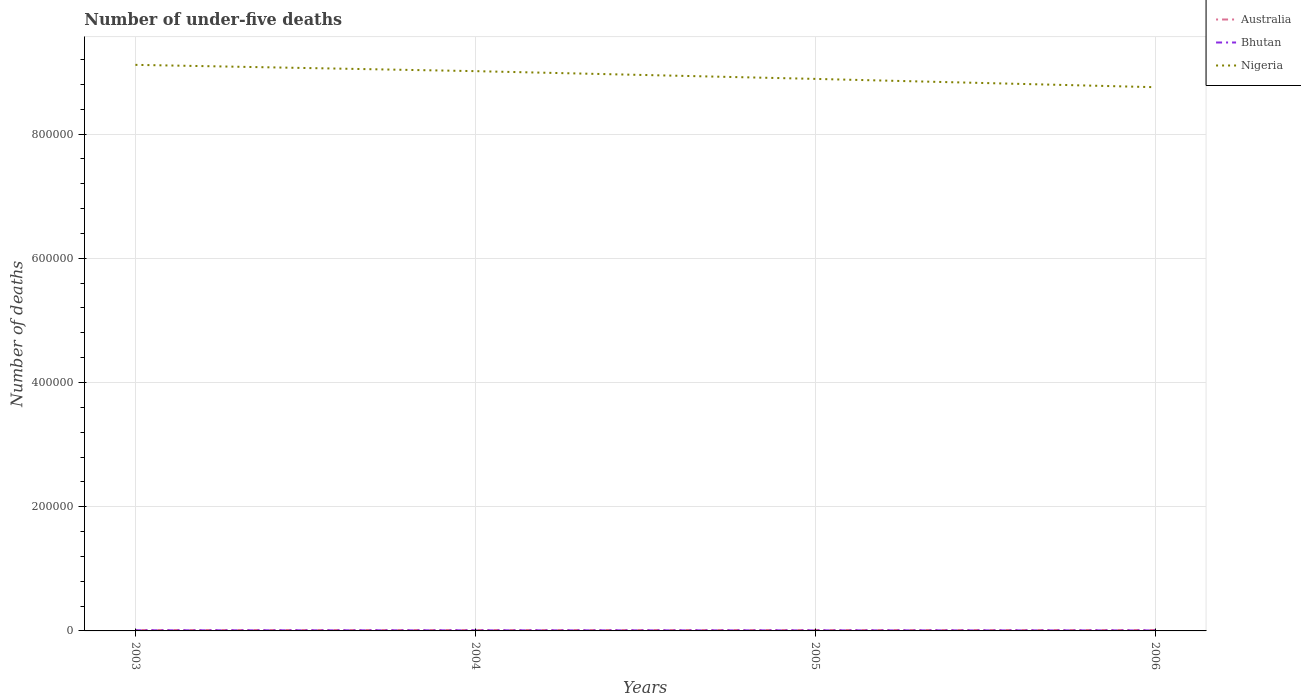How many different coloured lines are there?
Give a very brief answer. 3. Does the line corresponding to Bhutan intersect with the line corresponding to Nigeria?
Offer a terse response. No. Across all years, what is the maximum number of under-five deaths in Bhutan?
Ensure brevity in your answer.  812. What is the total number of under-five deaths in Nigeria in the graph?
Make the answer very short. 3.60e+04. What is the difference between the highest and the second highest number of under-five deaths in Australia?
Provide a succinct answer. 24. What is the difference between the highest and the lowest number of under-five deaths in Bhutan?
Your response must be concise. 2. Is the number of under-five deaths in Nigeria strictly greater than the number of under-five deaths in Bhutan over the years?
Make the answer very short. No. How many lines are there?
Your answer should be compact. 3. How many years are there in the graph?
Your answer should be compact. 4. What is the difference between two consecutive major ticks on the Y-axis?
Offer a very short reply. 2.00e+05. Does the graph contain any zero values?
Your response must be concise. No. Does the graph contain grids?
Keep it short and to the point. Yes. Where does the legend appear in the graph?
Your answer should be compact. Top right. How many legend labels are there?
Offer a terse response. 3. How are the legend labels stacked?
Ensure brevity in your answer.  Vertical. What is the title of the graph?
Ensure brevity in your answer.  Number of under-five deaths. What is the label or title of the X-axis?
Give a very brief answer. Years. What is the label or title of the Y-axis?
Make the answer very short. Number of deaths. What is the Number of deaths in Australia in 2003?
Provide a short and direct response. 1472. What is the Number of deaths of Bhutan in 2003?
Give a very brief answer. 1003. What is the Number of deaths of Nigeria in 2003?
Make the answer very short. 9.12e+05. What is the Number of deaths of Australia in 2004?
Provide a succinct answer. 1470. What is the Number of deaths of Bhutan in 2004?
Your response must be concise. 926. What is the Number of deaths of Nigeria in 2004?
Give a very brief answer. 9.01e+05. What is the Number of deaths of Australia in 2005?
Your response must be concise. 1458. What is the Number of deaths in Bhutan in 2005?
Your answer should be very brief. 862. What is the Number of deaths of Nigeria in 2005?
Offer a very short reply. 8.89e+05. What is the Number of deaths of Australia in 2006?
Your answer should be compact. 1482. What is the Number of deaths in Bhutan in 2006?
Offer a terse response. 812. What is the Number of deaths of Nigeria in 2006?
Offer a terse response. 8.76e+05. Across all years, what is the maximum Number of deaths in Australia?
Offer a terse response. 1482. Across all years, what is the maximum Number of deaths in Bhutan?
Your response must be concise. 1003. Across all years, what is the maximum Number of deaths of Nigeria?
Ensure brevity in your answer.  9.12e+05. Across all years, what is the minimum Number of deaths of Australia?
Your response must be concise. 1458. Across all years, what is the minimum Number of deaths of Bhutan?
Make the answer very short. 812. Across all years, what is the minimum Number of deaths of Nigeria?
Your answer should be very brief. 8.76e+05. What is the total Number of deaths in Australia in the graph?
Make the answer very short. 5882. What is the total Number of deaths of Bhutan in the graph?
Give a very brief answer. 3603. What is the total Number of deaths of Nigeria in the graph?
Your response must be concise. 3.58e+06. What is the difference between the Number of deaths of Australia in 2003 and that in 2004?
Your answer should be very brief. 2. What is the difference between the Number of deaths in Bhutan in 2003 and that in 2004?
Your answer should be compact. 77. What is the difference between the Number of deaths in Nigeria in 2003 and that in 2004?
Your response must be concise. 1.01e+04. What is the difference between the Number of deaths in Australia in 2003 and that in 2005?
Provide a short and direct response. 14. What is the difference between the Number of deaths of Bhutan in 2003 and that in 2005?
Provide a succinct answer. 141. What is the difference between the Number of deaths of Nigeria in 2003 and that in 2005?
Your answer should be compact. 2.26e+04. What is the difference between the Number of deaths in Australia in 2003 and that in 2006?
Your response must be concise. -10. What is the difference between the Number of deaths in Bhutan in 2003 and that in 2006?
Offer a very short reply. 191. What is the difference between the Number of deaths of Nigeria in 2003 and that in 2006?
Give a very brief answer. 3.60e+04. What is the difference between the Number of deaths in Bhutan in 2004 and that in 2005?
Make the answer very short. 64. What is the difference between the Number of deaths of Nigeria in 2004 and that in 2005?
Offer a very short reply. 1.25e+04. What is the difference between the Number of deaths in Australia in 2004 and that in 2006?
Offer a very short reply. -12. What is the difference between the Number of deaths of Bhutan in 2004 and that in 2006?
Give a very brief answer. 114. What is the difference between the Number of deaths in Nigeria in 2004 and that in 2006?
Offer a very short reply. 2.58e+04. What is the difference between the Number of deaths in Australia in 2005 and that in 2006?
Your response must be concise. -24. What is the difference between the Number of deaths of Bhutan in 2005 and that in 2006?
Your answer should be very brief. 50. What is the difference between the Number of deaths of Nigeria in 2005 and that in 2006?
Your response must be concise. 1.34e+04. What is the difference between the Number of deaths in Australia in 2003 and the Number of deaths in Bhutan in 2004?
Provide a short and direct response. 546. What is the difference between the Number of deaths of Australia in 2003 and the Number of deaths of Nigeria in 2004?
Ensure brevity in your answer.  -9.00e+05. What is the difference between the Number of deaths of Bhutan in 2003 and the Number of deaths of Nigeria in 2004?
Make the answer very short. -9.00e+05. What is the difference between the Number of deaths of Australia in 2003 and the Number of deaths of Bhutan in 2005?
Make the answer very short. 610. What is the difference between the Number of deaths in Australia in 2003 and the Number of deaths in Nigeria in 2005?
Your answer should be very brief. -8.87e+05. What is the difference between the Number of deaths of Bhutan in 2003 and the Number of deaths of Nigeria in 2005?
Keep it short and to the point. -8.88e+05. What is the difference between the Number of deaths in Australia in 2003 and the Number of deaths in Bhutan in 2006?
Offer a terse response. 660. What is the difference between the Number of deaths in Australia in 2003 and the Number of deaths in Nigeria in 2006?
Ensure brevity in your answer.  -8.74e+05. What is the difference between the Number of deaths in Bhutan in 2003 and the Number of deaths in Nigeria in 2006?
Provide a succinct answer. -8.75e+05. What is the difference between the Number of deaths of Australia in 2004 and the Number of deaths of Bhutan in 2005?
Ensure brevity in your answer.  608. What is the difference between the Number of deaths of Australia in 2004 and the Number of deaths of Nigeria in 2005?
Make the answer very short. -8.87e+05. What is the difference between the Number of deaths in Bhutan in 2004 and the Number of deaths in Nigeria in 2005?
Offer a very short reply. -8.88e+05. What is the difference between the Number of deaths of Australia in 2004 and the Number of deaths of Bhutan in 2006?
Ensure brevity in your answer.  658. What is the difference between the Number of deaths in Australia in 2004 and the Number of deaths in Nigeria in 2006?
Give a very brief answer. -8.74e+05. What is the difference between the Number of deaths in Bhutan in 2004 and the Number of deaths in Nigeria in 2006?
Provide a short and direct response. -8.75e+05. What is the difference between the Number of deaths in Australia in 2005 and the Number of deaths in Bhutan in 2006?
Provide a short and direct response. 646. What is the difference between the Number of deaths in Australia in 2005 and the Number of deaths in Nigeria in 2006?
Your answer should be very brief. -8.74e+05. What is the difference between the Number of deaths in Bhutan in 2005 and the Number of deaths in Nigeria in 2006?
Ensure brevity in your answer.  -8.75e+05. What is the average Number of deaths in Australia per year?
Offer a terse response. 1470.5. What is the average Number of deaths of Bhutan per year?
Ensure brevity in your answer.  900.75. What is the average Number of deaths of Nigeria per year?
Keep it short and to the point. 8.94e+05. In the year 2003, what is the difference between the Number of deaths in Australia and Number of deaths in Bhutan?
Ensure brevity in your answer.  469. In the year 2003, what is the difference between the Number of deaths in Australia and Number of deaths in Nigeria?
Your answer should be compact. -9.10e+05. In the year 2003, what is the difference between the Number of deaths of Bhutan and Number of deaths of Nigeria?
Ensure brevity in your answer.  -9.11e+05. In the year 2004, what is the difference between the Number of deaths of Australia and Number of deaths of Bhutan?
Make the answer very short. 544. In the year 2004, what is the difference between the Number of deaths in Australia and Number of deaths in Nigeria?
Keep it short and to the point. -9.00e+05. In the year 2004, what is the difference between the Number of deaths in Bhutan and Number of deaths in Nigeria?
Your response must be concise. -9.00e+05. In the year 2005, what is the difference between the Number of deaths in Australia and Number of deaths in Bhutan?
Ensure brevity in your answer.  596. In the year 2005, what is the difference between the Number of deaths in Australia and Number of deaths in Nigeria?
Your response must be concise. -8.87e+05. In the year 2005, what is the difference between the Number of deaths in Bhutan and Number of deaths in Nigeria?
Make the answer very short. -8.88e+05. In the year 2006, what is the difference between the Number of deaths in Australia and Number of deaths in Bhutan?
Provide a short and direct response. 670. In the year 2006, what is the difference between the Number of deaths of Australia and Number of deaths of Nigeria?
Ensure brevity in your answer.  -8.74e+05. In the year 2006, what is the difference between the Number of deaths of Bhutan and Number of deaths of Nigeria?
Offer a terse response. -8.75e+05. What is the ratio of the Number of deaths of Australia in 2003 to that in 2004?
Offer a very short reply. 1. What is the ratio of the Number of deaths of Bhutan in 2003 to that in 2004?
Provide a succinct answer. 1.08. What is the ratio of the Number of deaths of Nigeria in 2003 to that in 2004?
Offer a terse response. 1.01. What is the ratio of the Number of deaths of Australia in 2003 to that in 2005?
Provide a succinct answer. 1.01. What is the ratio of the Number of deaths in Bhutan in 2003 to that in 2005?
Provide a short and direct response. 1.16. What is the ratio of the Number of deaths of Nigeria in 2003 to that in 2005?
Ensure brevity in your answer.  1.03. What is the ratio of the Number of deaths of Australia in 2003 to that in 2006?
Provide a succinct answer. 0.99. What is the ratio of the Number of deaths of Bhutan in 2003 to that in 2006?
Keep it short and to the point. 1.24. What is the ratio of the Number of deaths of Nigeria in 2003 to that in 2006?
Give a very brief answer. 1.04. What is the ratio of the Number of deaths in Australia in 2004 to that in 2005?
Your answer should be very brief. 1.01. What is the ratio of the Number of deaths in Bhutan in 2004 to that in 2005?
Your answer should be very brief. 1.07. What is the ratio of the Number of deaths in Nigeria in 2004 to that in 2005?
Provide a short and direct response. 1.01. What is the ratio of the Number of deaths in Australia in 2004 to that in 2006?
Keep it short and to the point. 0.99. What is the ratio of the Number of deaths of Bhutan in 2004 to that in 2006?
Your response must be concise. 1.14. What is the ratio of the Number of deaths in Nigeria in 2004 to that in 2006?
Your answer should be very brief. 1.03. What is the ratio of the Number of deaths in Australia in 2005 to that in 2006?
Your answer should be very brief. 0.98. What is the ratio of the Number of deaths in Bhutan in 2005 to that in 2006?
Your response must be concise. 1.06. What is the ratio of the Number of deaths in Nigeria in 2005 to that in 2006?
Give a very brief answer. 1.02. What is the difference between the highest and the second highest Number of deaths in Australia?
Offer a very short reply. 10. What is the difference between the highest and the second highest Number of deaths of Bhutan?
Offer a very short reply. 77. What is the difference between the highest and the second highest Number of deaths of Nigeria?
Keep it short and to the point. 1.01e+04. What is the difference between the highest and the lowest Number of deaths in Bhutan?
Keep it short and to the point. 191. What is the difference between the highest and the lowest Number of deaths of Nigeria?
Keep it short and to the point. 3.60e+04. 